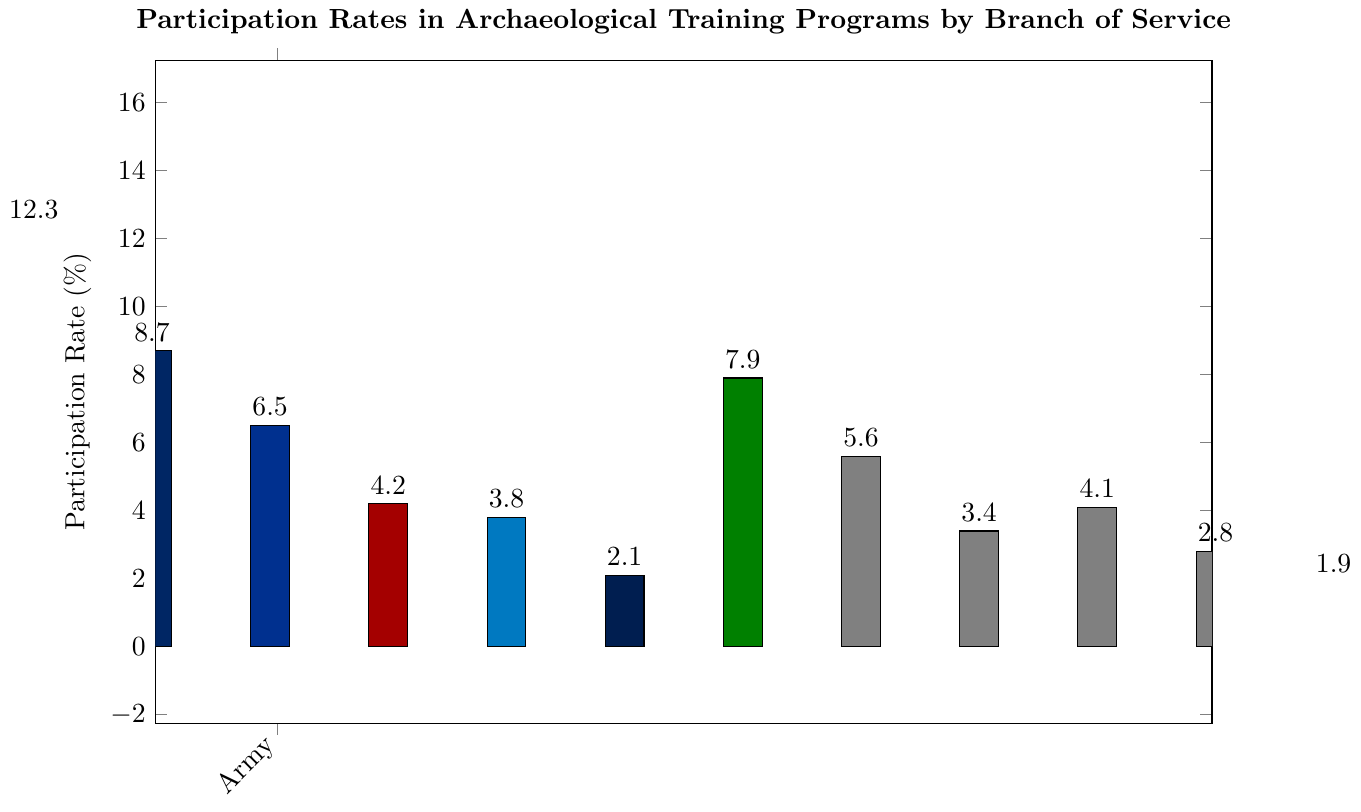Which branch has the highest participation rate in archaeological training programs? Observing the height of the bars, the Army has the highest participation rate at 12.3%.
Answer: Army What is the total participation rate for all Reserve branches combined? Sum the participation rates of all Reserve branches: 5.6% (Army Reserve) + 3.4% (Navy Reserve) + 4.1% (Air Force Reserve) + 2.8% (Marine Corps Reserve) + 1.9% (Coast Guard Reserve) = 17.8%.
Answer: 17.8% Which branch has a higher participation rate, the Marines or the Marine Corps Reserve? Compare the heights of the bars for the Marines (4.2%) and the Marine Corps Reserve (2.8%). The Marines have a higher participation rate.
Answer: Marines What's the difference in participation rates between the Air Force and the Navy? Subtract the participation rate of the Air Force (6.5%) from that of the Navy (8.7%): 8.7% - 6.5% = 2.2%.
Answer: 2.2% How does the participation rate of the National Guard compare to that of the Navy? Compare the heights of the bars: the National Guard has a participation rate of 7.9% while the Navy has 8.7%, so the Navy has a higher rate.
Answer: Navy has a higher rate What is the average participation rate across all branches? Add all participation rates: 12.3% + 8.7% + 6.5% + 4.2% + 3.8% + 2.1% + 7.9% + 5.6% + 3.4% + 4.1% + 2.8% + 1.9% = 63.3%. Divide by the number of branches (12) to get the average: 63.3% / 12 = 5.275%.
Answer: 5.275% What is the participation rate of the Coast Guard Reserve relative to the Coast Guard? Both rates need to be compared where the Coast Guard Reserve is 1.9% and the Coast Guard is 3.8%. The Coast Guard participation rate is exactly double that of the Coast Guard Reserve.
Answer: Half Which branch has the lowest participation rate, and what is it? By observing the heights of the bars, the Space Force has the lowest participation rate at 2.1%.
Answer: Space Force, 2.1% Is the participation rate of the Army more than twice that of the Marines? The Army participation rate is 12.3%, and the Marines' is 4.2%. Doubling the Marines' rate gives 8.4%, which is less than the Army's rate of 12.3%, thus the Army's rate is more than twice.
Answer: Yes What is the median participation rate across all branches? List the rates in ascending order: 1.9%, 2.1%, 2.8%, 3.4%, 3.8%, 4.1%, 4.2%, 5.6%, 6.5%, 7.9%, 8.7%, 12.3%. The data set is even and has 12 values; the median is the average of the 6th and 7th values: (4.1% + 4.2%) / 2 = 4.15%.
Answer: 4.15% 